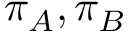Convert formula to latex. <formula><loc_0><loc_0><loc_500><loc_500>\pi _ { A } , \pi _ { B }</formula> 